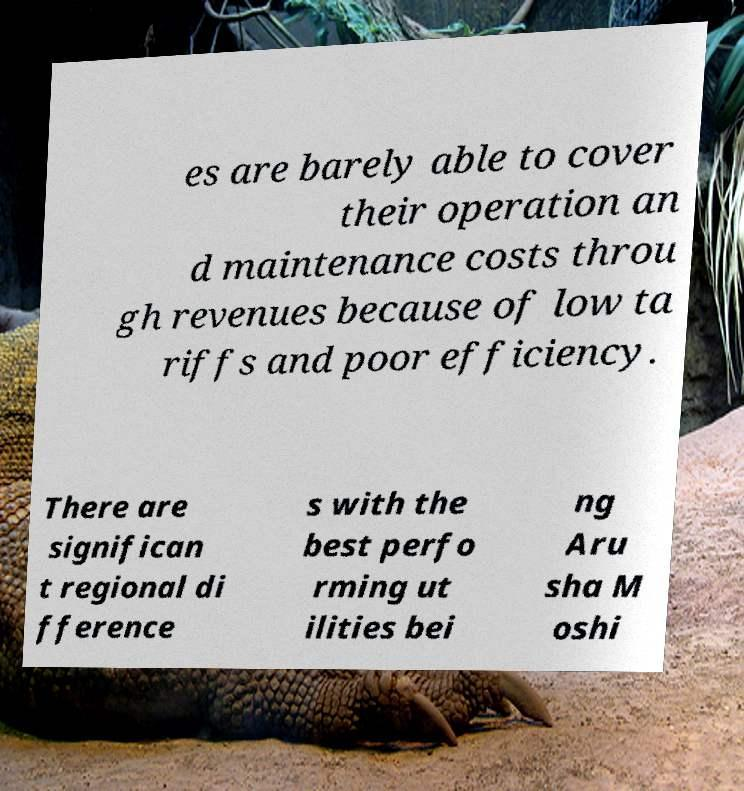There's text embedded in this image that I need extracted. Can you transcribe it verbatim? es are barely able to cover their operation an d maintenance costs throu gh revenues because of low ta riffs and poor efficiency. There are significan t regional di fference s with the best perfo rming ut ilities bei ng Aru sha M oshi 